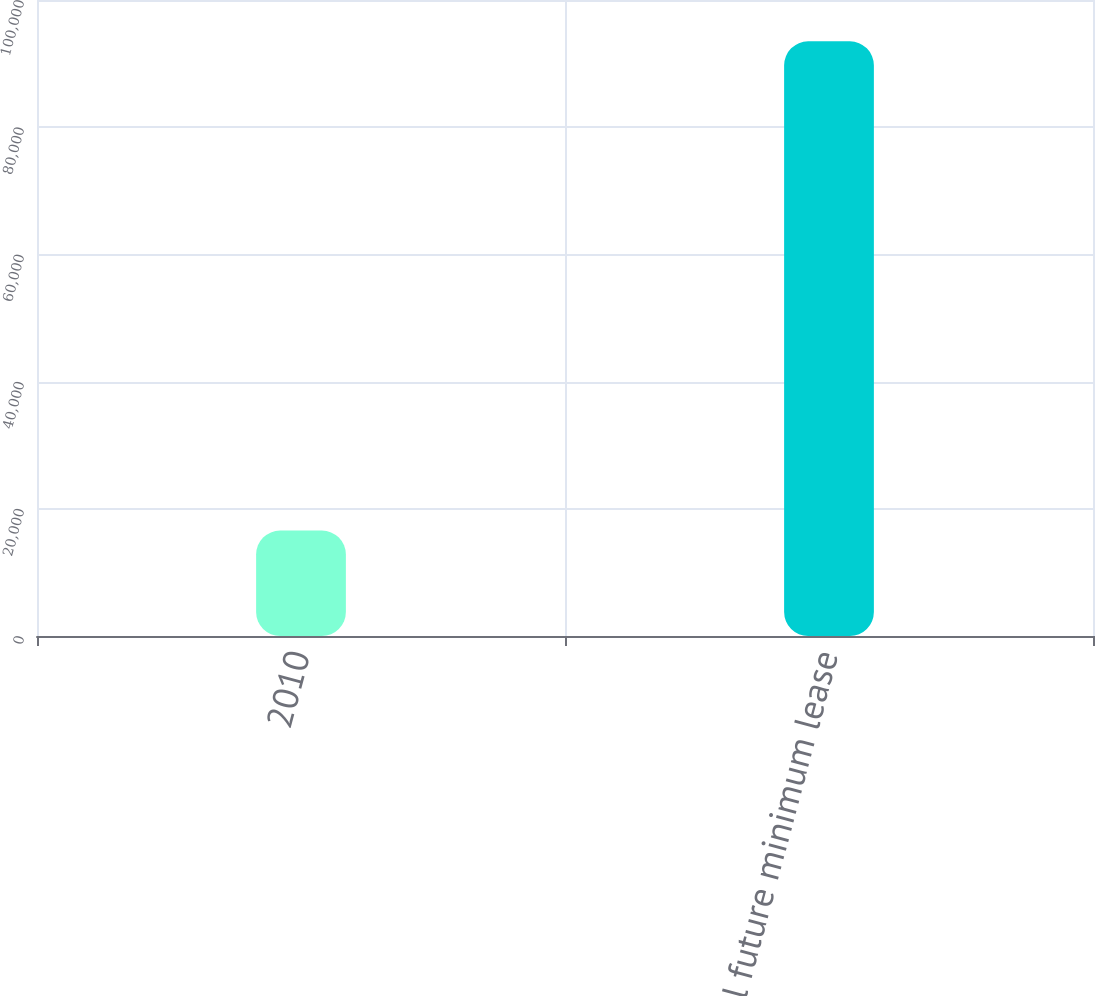<chart> <loc_0><loc_0><loc_500><loc_500><bar_chart><fcel>2010<fcel>Total future minimum lease<nl><fcel>16579<fcel>93504<nl></chart> 